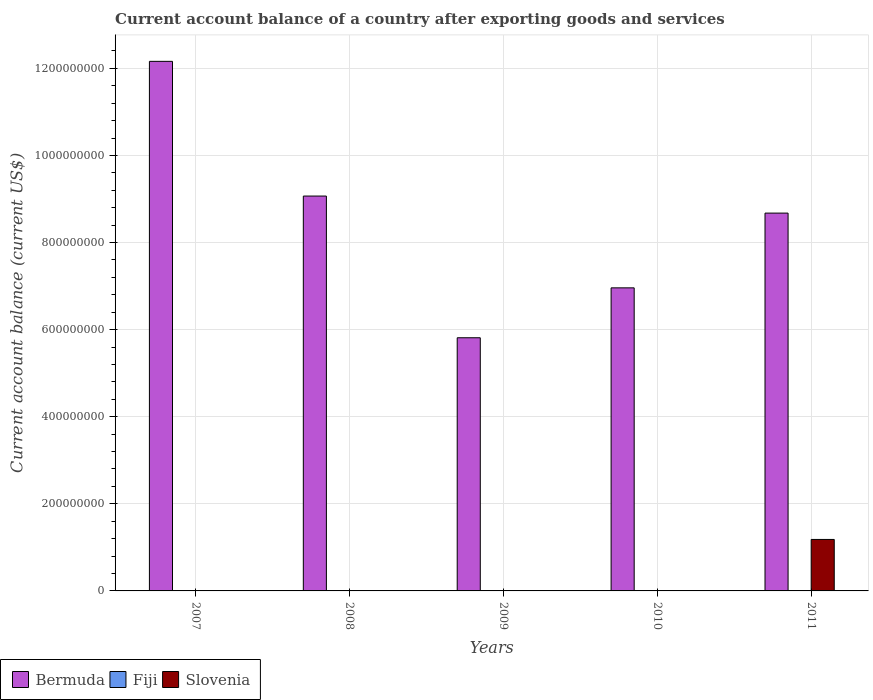Are the number of bars on each tick of the X-axis equal?
Offer a very short reply. No. How many bars are there on the 5th tick from the left?
Make the answer very short. 2. How many bars are there on the 1st tick from the right?
Keep it short and to the point. 2. What is the label of the 5th group of bars from the left?
Your answer should be very brief. 2011. What is the account balance in Bermuda in 2010?
Keep it short and to the point. 6.96e+08. Across all years, what is the maximum account balance in Bermuda?
Your response must be concise. 1.22e+09. Across all years, what is the minimum account balance in Slovenia?
Provide a succinct answer. 0. What is the total account balance in Slovenia in the graph?
Offer a very short reply. 1.18e+08. What is the difference between the account balance in Bermuda in 2009 and that in 2011?
Keep it short and to the point. -2.86e+08. What is the difference between the account balance in Bermuda in 2010 and the account balance in Fiji in 2009?
Ensure brevity in your answer.  6.96e+08. What is the average account balance in Bermuda per year?
Give a very brief answer. 8.54e+08. In how many years, is the account balance in Slovenia greater than 600000000 US$?
Your response must be concise. 0. What is the ratio of the account balance in Bermuda in 2008 to that in 2011?
Make the answer very short. 1.05. Is the account balance in Bermuda in 2007 less than that in 2008?
Provide a succinct answer. No. What is the difference between the highest and the lowest account balance in Slovenia?
Make the answer very short. 1.18e+08. In how many years, is the account balance in Bermuda greater than the average account balance in Bermuda taken over all years?
Your answer should be compact. 3. Is it the case that in every year, the sum of the account balance in Slovenia and account balance in Fiji is greater than the account balance in Bermuda?
Offer a very short reply. No. How many years are there in the graph?
Provide a succinct answer. 5. Does the graph contain grids?
Your answer should be very brief. Yes. Where does the legend appear in the graph?
Offer a very short reply. Bottom left. How many legend labels are there?
Your answer should be compact. 3. How are the legend labels stacked?
Offer a very short reply. Horizontal. What is the title of the graph?
Provide a succinct answer. Current account balance of a country after exporting goods and services. What is the label or title of the X-axis?
Offer a terse response. Years. What is the label or title of the Y-axis?
Offer a terse response. Current account balance (current US$). What is the Current account balance (current US$) in Bermuda in 2007?
Make the answer very short. 1.22e+09. What is the Current account balance (current US$) of Fiji in 2007?
Provide a short and direct response. 0. What is the Current account balance (current US$) in Bermuda in 2008?
Keep it short and to the point. 9.07e+08. What is the Current account balance (current US$) in Fiji in 2008?
Give a very brief answer. 0. What is the Current account balance (current US$) in Slovenia in 2008?
Make the answer very short. 0. What is the Current account balance (current US$) in Bermuda in 2009?
Give a very brief answer. 5.81e+08. What is the Current account balance (current US$) of Slovenia in 2009?
Offer a very short reply. 0. What is the Current account balance (current US$) of Bermuda in 2010?
Your answer should be very brief. 6.96e+08. What is the Current account balance (current US$) in Bermuda in 2011?
Provide a succinct answer. 8.68e+08. What is the Current account balance (current US$) in Slovenia in 2011?
Offer a very short reply. 1.18e+08. Across all years, what is the maximum Current account balance (current US$) of Bermuda?
Ensure brevity in your answer.  1.22e+09. Across all years, what is the maximum Current account balance (current US$) of Slovenia?
Ensure brevity in your answer.  1.18e+08. Across all years, what is the minimum Current account balance (current US$) of Bermuda?
Your answer should be compact. 5.81e+08. What is the total Current account balance (current US$) in Bermuda in the graph?
Provide a succinct answer. 4.27e+09. What is the total Current account balance (current US$) in Slovenia in the graph?
Offer a terse response. 1.18e+08. What is the difference between the Current account balance (current US$) of Bermuda in 2007 and that in 2008?
Your response must be concise. 3.09e+08. What is the difference between the Current account balance (current US$) in Bermuda in 2007 and that in 2009?
Provide a short and direct response. 6.35e+08. What is the difference between the Current account balance (current US$) of Bermuda in 2007 and that in 2010?
Make the answer very short. 5.20e+08. What is the difference between the Current account balance (current US$) in Bermuda in 2007 and that in 2011?
Give a very brief answer. 3.48e+08. What is the difference between the Current account balance (current US$) of Bermuda in 2008 and that in 2009?
Your answer should be compact. 3.25e+08. What is the difference between the Current account balance (current US$) in Bermuda in 2008 and that in 2010?
Your answer should be compact. 2.11e+08. What is the difference between the Current account balance (current US$) in Bermuda in 2008 and that in 2011?
Keep it short and to the point. 3.91e+07. What is the difference between the Current account balance (current US$) in Bermuda in 2009 and that in 2010?
Provide a short and direct response. -1.15e+08. What is the difference between the Current account balance (current US$) in Bermuda in 2009 and that in 2011?
Keep it short and to the point. -2.86e+08. What is the difference between the Current account balance (current US$) in Bermuda in 2010 and that in 2011?
Your response must be concise. -1.72e+08. What is the difference between the Current account balance (current US$) in Bermuda in 2007 and the Current account balance (current US$) in Slovenia in 2011?
Provide a short and direct response. 1.10e+09. What is the difference between the Current account balance (current US$) of Bermuda in 2008 and the Current account balance (current US$) of Slovenia in 2011?
Offer a terse response. 7.89e+08. What is the difference between the Current account balance (current US$) of Bermuda in 2009 and the Current account balance (current US$) of Slovenia in 2011?
Offer a very short reply. 4.63e+08. What is the difference between the Current account balance (current US$) in Bermuda in 2010 and the Current account balance (current US$) in Slovenia in 2011?
Give a very brief answer. 5.78e+08. What is the average Current account balance (current US$) of Bermuda per year?
Give a very brief answer. 8.54e+08. What is the average Current account balance (current US$) in Fiji per year?
Your answer should be compact. 0. What is the average Current account balance (current US$) in Slovenia per year?
Provide a succinct answer. 2.36e+07. In the year 2011, what is the difference between the Current account balance (current US$) of Bermuda and Current account balance (current US$) of Slovenia?
Your answer should be very brief. 7.49e+08. What is the ratio of the Current account balance (current US$) of Bermuda in 2007 to that in 2008?
Provide a succinct answer. 1.34. What is the ratio of the Current account balance (current US$) in Bermuda in 2007 to that in 2009?
Provide a succinct answer. 2.09. What is the ratio of the Current account balance (current US$) of Bermuda in 2007 to that in 2010?
Give a very brief answer. 1.75. What is the ratio of the Current account balance (current US$) of Bermuda in 2007 to that in 2011?
Ensure brevity in your answer.  1.4. What is the ratio of the Current account balance (current US$) in Bermuda in 2008 to that in 2009?
Offer a very short reply. 1.56. What is the ratio of the Current account balance (current US$) in Bermuda in 2008 to that in 2010?
Provide a short and direct response. 1.3. What is the ratio of the Current account balance (current US$) in Bermuda in 2008 to that in 2011?
Your answer should be compact. 1.05. What is the ratio of the Current account balance (current US$) of Bermuda in 2009 to that in 2010?
Ensure brevity in your answer.  0.84. What is the ratio of the Current account balance (current US$) of Bermuda in 2009 to that in 2011?
Provide a succinct answer. 0.67. What is the ratio of the Current account balance (current US$) of Bermuda in 2010 to that in 2011?
Your answer should be compact. 0.8. What is the difference between the highest and the second highest Current account balance (current US$) in Bermuda?
Keep it short and to the point. 3.09e+08. What is the difference between the highest and the lowest Current account balance (current US$) in Bermuda?
Your answer should be very brief. 6.35e+08. What is the difference between the highest and the lowest Current account balance (current US$) in Slovenia?
Give a very brief answer. 1.18e+08. 